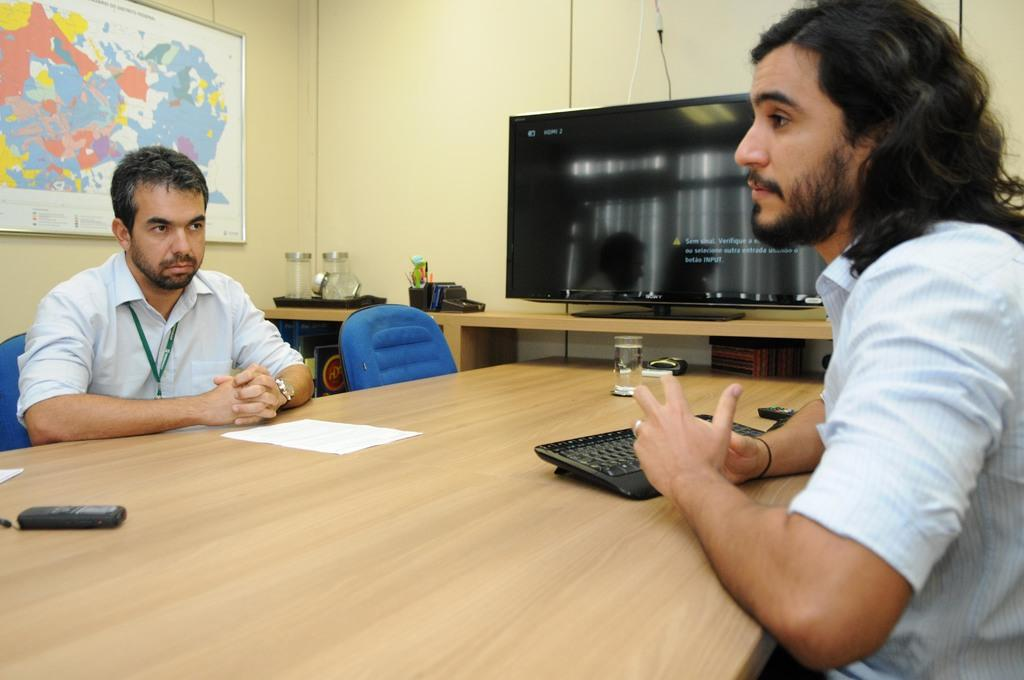How many people are sitting on the chair in the image? There are two people sitting on a chair in the image. What is present on the table in the image? There is a pen, a mobile, and a glass on the table in the image. What can be seen in the background of the image? There is a world map and a TV in the background. What type of toothpaste is being used by the people sitting on the chair in the image? There is no toothpaste present in the image. What route are the people planning to take based on the world map in the background? The image does not show any indication of the people planning a route or referring to the world map. 